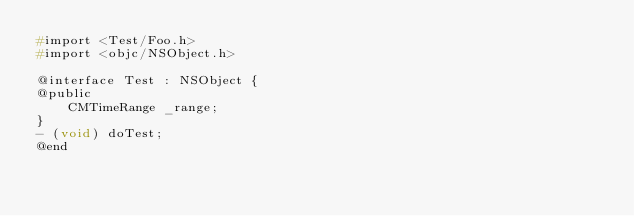Convert code to text. <code><loc_0><loc_0><loc_500><loc_500><_C_>#import <Test/Foo.h>
#import <objc/NSObject.h>

@interface Test : NSObject {
@public
    CMTimeRange _range;
}
- (void) doTest;
@end

</code> 